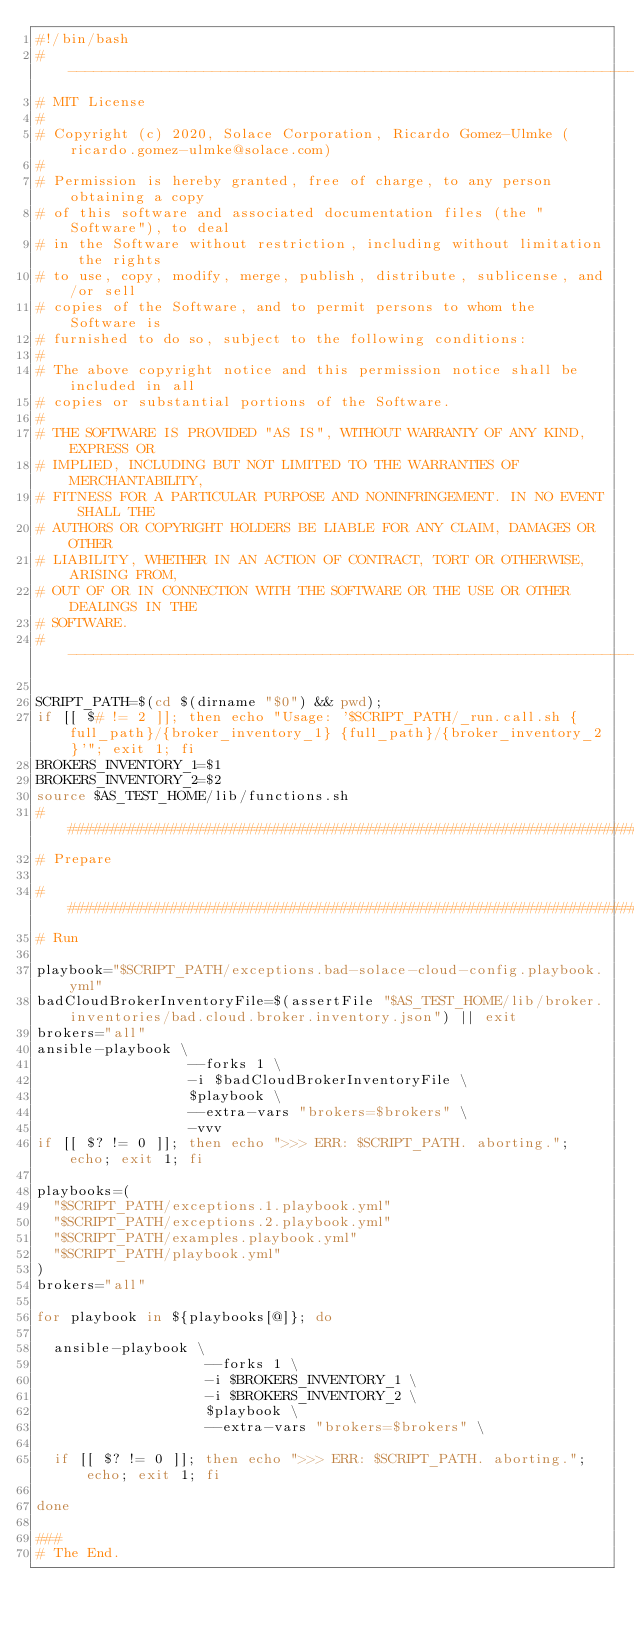Convert code to text. <code><loc_0><loc_0><loc_500><loc_500><_Bash_>#!/bin/bash
# ---------------------------------------------------------------------------------------------
# MIT License
#
# Copyright (c) 2020, Solace Corporation, Ricardo Gomez-Ulmke (ricardo.gomez-ulmke@solace.com)
#
# Permission is hereby granted, free of charge, to any person obtaining a copy
# of this software and associated documentation files (the "Software"), to deal
# in the Software without restriction, including without limitation the rights
# to use, copy, modify, merge, publish, distribute, sublicense, and/or sell
# copies of the Software, and to permit persons to whom the Software is
# furnished to do so, subject to the following conditions:
#
# The above copyright notice and this permission notice shall be included in all
# copies or substantial portions of the Software.
#
# THE SOFTWARE IS PROVIDED "AS IS", WITHOUT WARRANTY OF ANY KIND, EXPRESS OR
# IMPLIED, INCLUDING BUT NOT LIMITED TO THE WARRANTIES OF MERCHANTABILITY,
# FITNESS FOR A PARTICULAR PURPOSE AND NONINFRINGEMENT. IN NO EVENT SHALL THE
# AUTHORS OR COPYRIGHT HOLDERS BE LIABLE FOR ANY CLAIM, DAMAGES OR OTHER
# LIABILITY, WHETHER IN AN ACTION OF CONTRACT, TORT OR OTHERWISE, ARISING FROM,
# OUT OF OR IN CONNECTION WITH THE SOFTWARE OR THE USE OR OTHER DEALINGS IN THE
# SOFTWARE.
# ---------------------------------------------------------------------------------------------

SCRIPT_PATH=$(cd $(dirname "$0") && pwd);
if [[ $# != 2 ]]; then echo "Usage: '$SCRIPT_PATH/_run.call.sh {full_path}/{broker_inventory_1} {full_path}/{broker_inventory_2}'"; exit 1; fi
BROKERS_INVENTORY_1=$1
BROKERS_INVENTORY_2=$2
source $AS_TEST_HOME/lib/functions.sh
##############################################################################################################################
# Prepare

##############################################################################################################################
# Run

playbook="$SCRIPT_PATH/exceptions.bad-solace-cloud-config.playbook.yml"
badCloudBrokerInventoryFile=$(assertFile "$AS_TEST_HOME/lib/broker.inventories/bad.cloud.broker.inventory.json") || exit
brokers="all"
ansible-playbook \
                  --forks 1 \
                  -i $badCloudBrokerInventoryFile \
                  $playbook \
                  --extra-vars "brokers=$brokers" \
                  -vvv
if [[ $? != 0 ]]; then echo ">>> ERR: $SCRIPT_PATH. aborting."; echo; exit 1; fi

playbooks=(
  "$SCRIPT_PATH/exceptions.1.playbook.yml"
  "$SCRIPT_PATH/exceptions.2.playbook.yml"
  "$SCRIPT_PATH/examples.playbook.yml"
  "$SCRIPT_PATH/playbook.yml"
)
brokers="all"

for playbook in ${playbooks[@]}; do

  ansible-playbook \
                    --forks 1 \
                    -i $BROKERS_INVENTORY_1 \
                    -i $BROKERS_INVENTORY_2 \
                    $playbook \
                    --extra-vars "brokers=$brokers" \

  if [[ $? != 0 ]]; then echo ">>> ERR: $SCRIPT_PATH. aborting."; echo; exit 1; fi

done

###
# The End.
</code> 